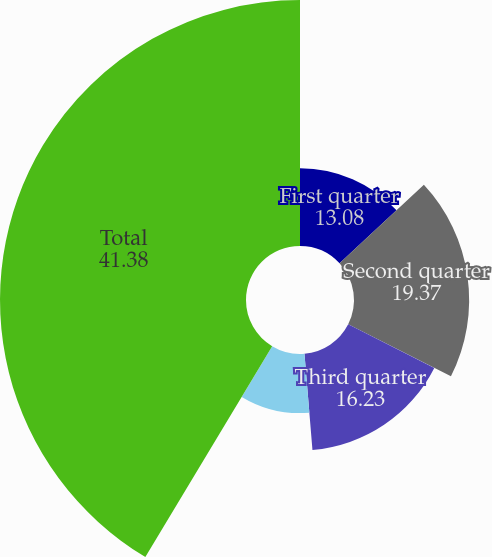Convert chart to OTSL. <chart><loc_0><loc_0><loc_500><loc_500><pie_chart><fcel>First quarter<fcel>Second quarter<fcel>Third quarter<fcel>Fourth quarter<fcel>Total<nl><fcel>13.08%<fcel>19.37%<fcel>16.23%<fcel>9.94%<fcel>41.38%<nl></chart> 